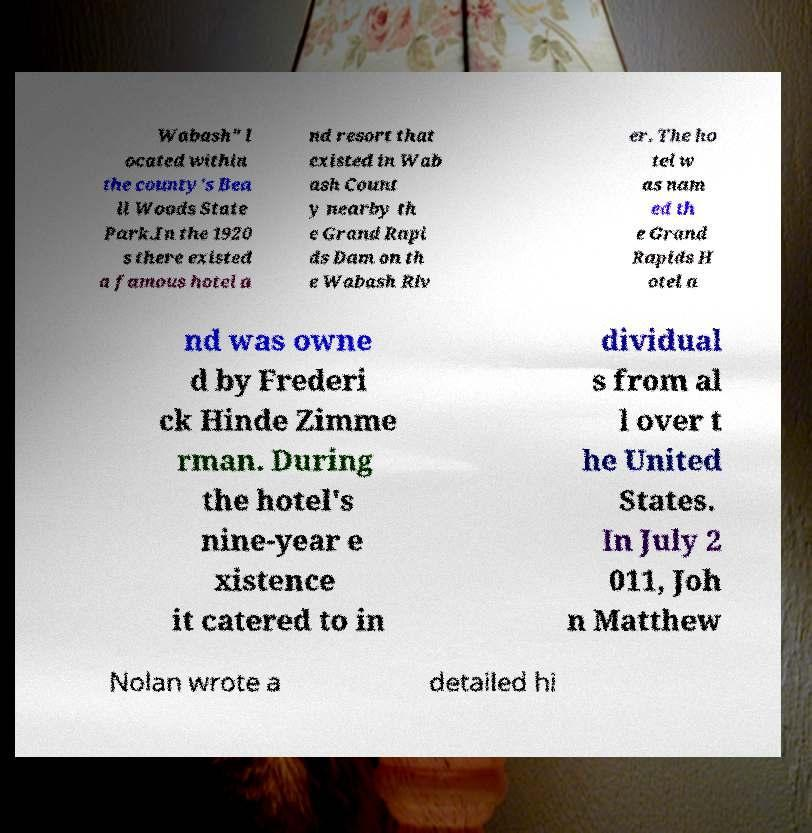Could you extract and type out the text from this image? Wabash" l ocated within the county's Bea ll Woods State Park.In the 1920 s there existed a famous hotel a nd resort that existed in Wab ash Count y nearby th e Grand Rapi ds Dam on th e Wabash Riv er. The ho tel w as nam ed th e Grand Rapids H otel a nd was owne d by Frederi ck Hinde Zimme rman. During the hotel's nine-year e xistence it catered to in dividual s from al l over t he United States. In July 2 011, Joh n Matthew Nolan wrote a detailed hi 